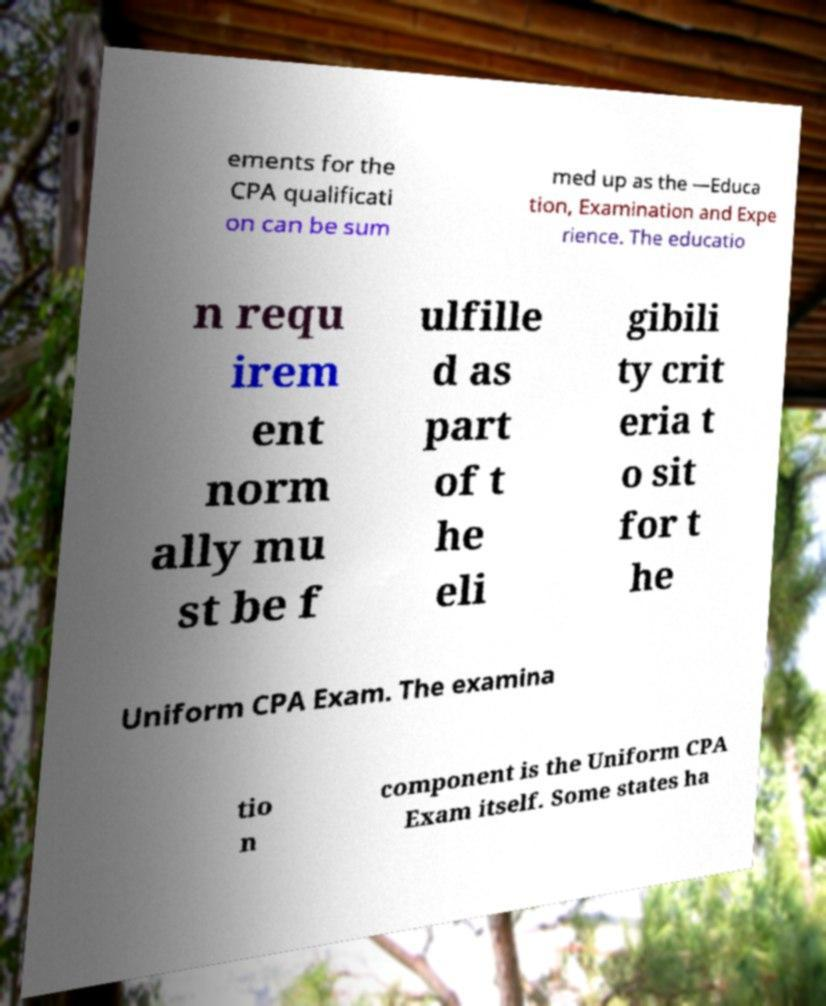Can you read and provide the text displayed in the image?This photo seems to have some interesting text. Can you extract and type it out for me? ements for the CPA qualificati on can be sum med up as the —Educa tion, Examination and Expe rience. The educatio n requ irem ent norm ally mu st be f ulfille d as part of t he eli gibili ty crit eria t o sit for t he Uniform CPA Exam. The examina tio n component is the Uniform CPA Exam itself. Some states ha 